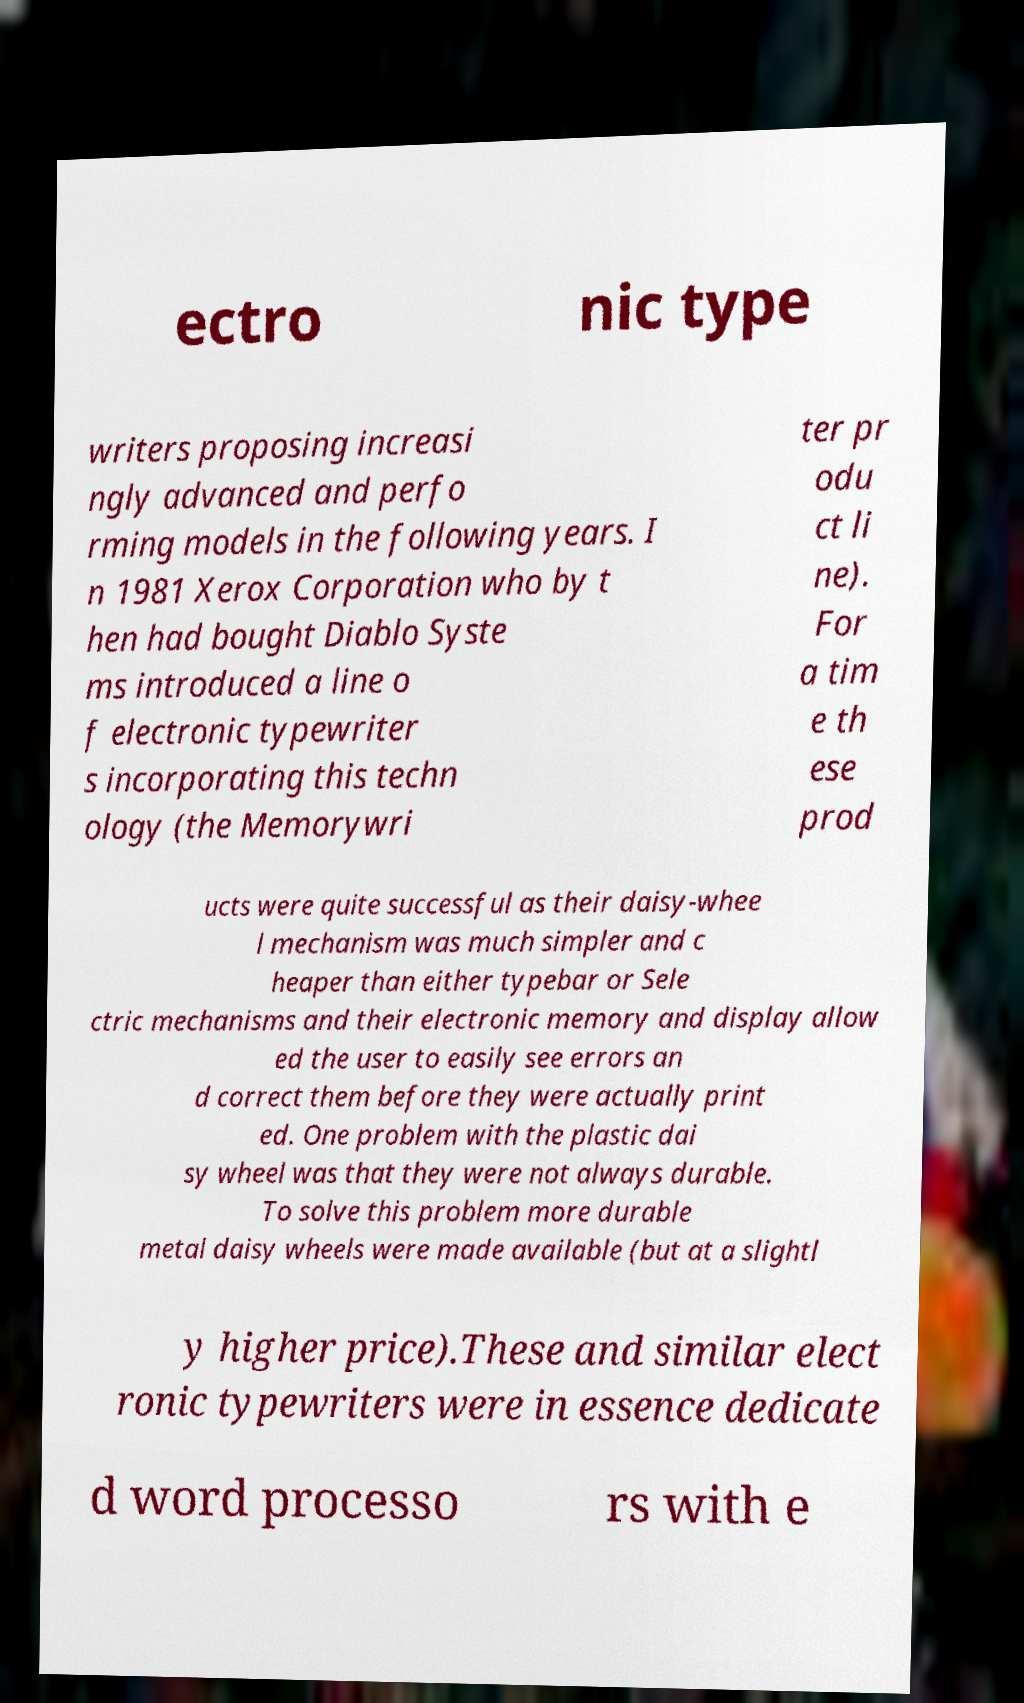Could you extract and type out the text from this image? ectro nic type writers proposing increasi ngly advanced and perfo rming models in the following years. I n 1981 Xerox Corporation who by t hen had bought Diablo Syste ms introduced a line o f electronic typewriter s incorporating this techn ology (the Memorywri ter pr odu ct li ne). For a tim e th ese prod ucts were quite successful as their daisy-whee l mechanism was much simpler and c heaper than either typebar or Sele ctric mechanisms and their electronic memory and display allow ed the user to easily see errors an d correct them before they were actually print ed. One problem with the plastic dai sy wheel was that they were not always durable. To solve this problem more durable metal daisy wheels were made available (but at a slightl y higher price).These and similar elect ronic typewriters were in essence dedicate d word processo rs with e 